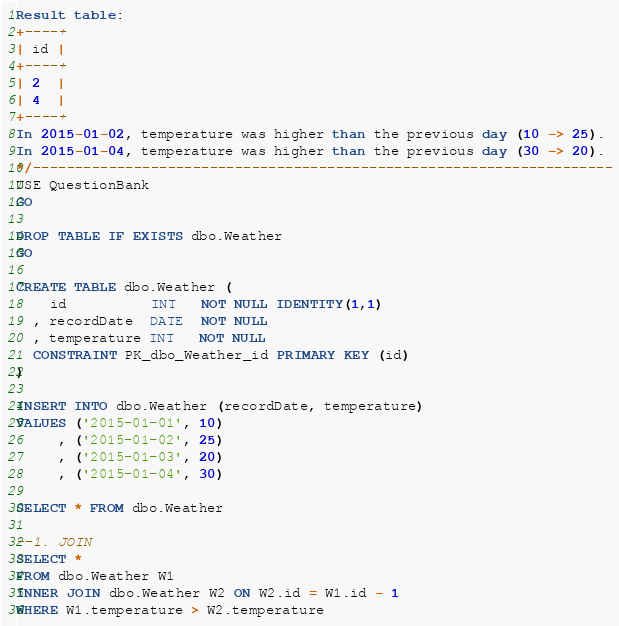Convert code to text. <code><loc_0><loc_0><loc_500><loc_500><_SQL_>Result table:
+----+
| id |
+----+
| 2  |
| 4  |
+----+
In 2015-01-02, temperature was higher than the previous day (10 -> 25).
In 2015-01-04, temperature was higher than the previous day (30 -> 20).
*/---------------------------------------------------------------------
USE QuestionBank
GO

DROP TABLE IF EXISTS dbo.Weather
GO

CREATE TABLE dbo.Weather (
	id          INT   NOT NULL IDENTITY(1,1)
  , recordDate  DATE  NOT NULL
  , temperature INT   NOT NULL
  CONSTRAINT PK_dbo_Weather_id PRIMARY KEY (id)
)

INSERT INTO dbo.Weather (recordDate, temperature)
VALUES ('2015-01-01', 10)
     , ('2015-01-02', 25)
	 , ('2015-01-03', 20)
	 , ('2015-01-04', 30)

SELECT * FROM dbo.Weather

--1. JOIN
SELECT * 
FROM dbo.Weather W1
INNER JOIN dbo.Weather W2 ON W2.id = W1.id - 1
WHERE W1.temperature > W2.temperature</code> 